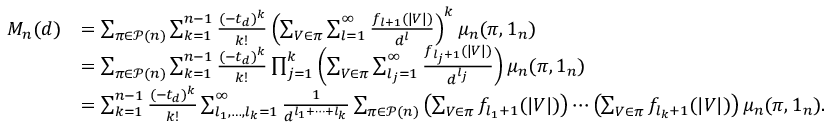<formula> <loc_0><loc_0><loc_500><loc_500>\begin{array} { r l } { M _ { n } ( d ) } & { = \sum _ { \pi \in \mathcal { P } ( n ) } \sum _ { k = 1 } ^ { n - 1 } \frac { ( - t _ { d } ) ^ { k } } { k ! } \left ( \sum _ { V \in \pi } \sum _ { l = 1 } ^ { \infty } \frac { f _ { l + 1 } ( | V | ) } { d ^ { l } } \right ) ^ { k } \mu _ { n } ( \pi , 1 _ { n } ) } \\ & { = \sum _ { \pi \in \mathcal { P } ( n ) } \sum _ { k = 1 } ^ { n - 1 } \frac { ( - t _ { d } ) ^ { k } } { k ! } \prod _ { j = 1 } ^ { k } \left ( \sum _ { V \in \pi } \sum _ { l _ { j } = 1 } ^ { \infty } \frac { f _ { l _ { j } + 1 } ( | V | ) } { d ^ { l _ { j } } } \right ) \mu _ { n } ( \pi , 1 _ { n } ) } \\ & { = \sum _ { k = 1 } ^ { n - 1 } \frac { ( - t _ { d } ) ^ { k } } { k ! } \sum _ { l _ { 1 } , \dots , l _ { k } = 1 } ^ { \infty } \frac { 1 } { d ^ { l _ { 1 } + \cdots + l _ { k } } } \sum _ { \pi \in \mathcal { P } ( n ) } \left ( \sum _ { V \in \pi } f _ { l _ { 1 } + 1 } ( | V | ) \right ) \cdots \left ( \sum _ { V \in \pi } f _ { l _ { k } + 1 } ( | V | ) \right ) \mu _ { n } ( \pi , 1 _ { n } ) . } \end{array}</formula> 